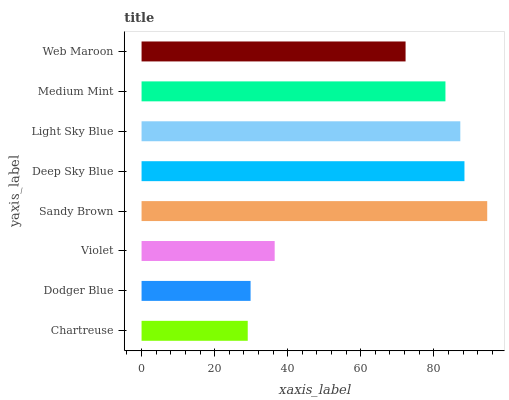Is Chartreuse the minimum?
Answer yes or no. Yes. Is Sandy Brown the maximum?
Answer yes or no. Yes. Is Dodger Blue the minimum?
Answer yes or no. No. Is Dodger Blue the maximum?
Answer yes or no. No. Is Dodger Blue greater than Chartreuse?
Answer yes or no. Yes. Is Chartreuse less than Dodger Blue?
Answer yes or no. Yes. Is Chartreuse greater than Dodger Blue?
Answer yes or no. No. Is Dodger Blue less than Chartreuse?
Answer yes or no. No. Is Medium Mint the high median?
Answer yes or no. Yes. Is Web Maroon the low median?
Answer yes or no. Yes. Is Deep Sky Blue the high median?
Answer yes or no. No. Is Medium Mint the low median?
Answer yes or no. No. 